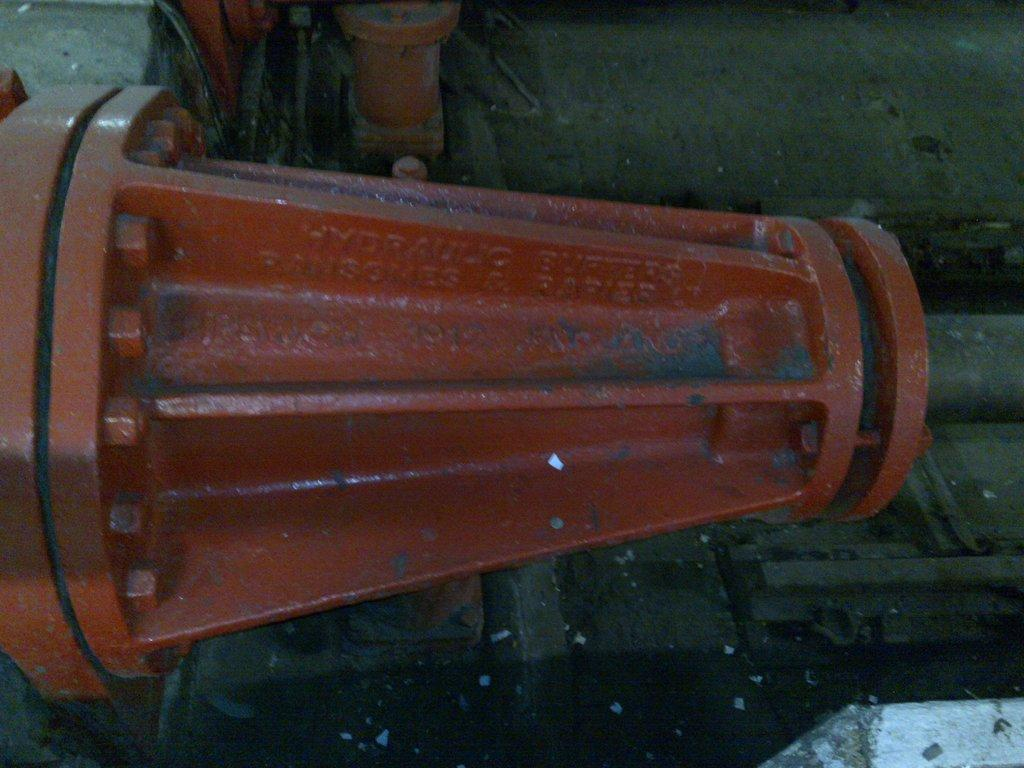What is the main subject of the image? The main subject of the image is a pipeline. How is the pipeline supported in the image? The pipeline is attached to poles in the image. What color is the pipeline in the image? The pipeline is red in color. What type of thread is used to create the title of the image? There is no title present in the image, and therefore no thread is used to create it. 